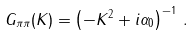Convert formula to latex. <formula><loc_0><loc_0><loc_500><loc_500>G _ { \pi \pi } ( K ) = \left ( - K ^ { 2 } + i \alpha _ { 0 } \right ) ^ { - 1 } \, .</formula> 